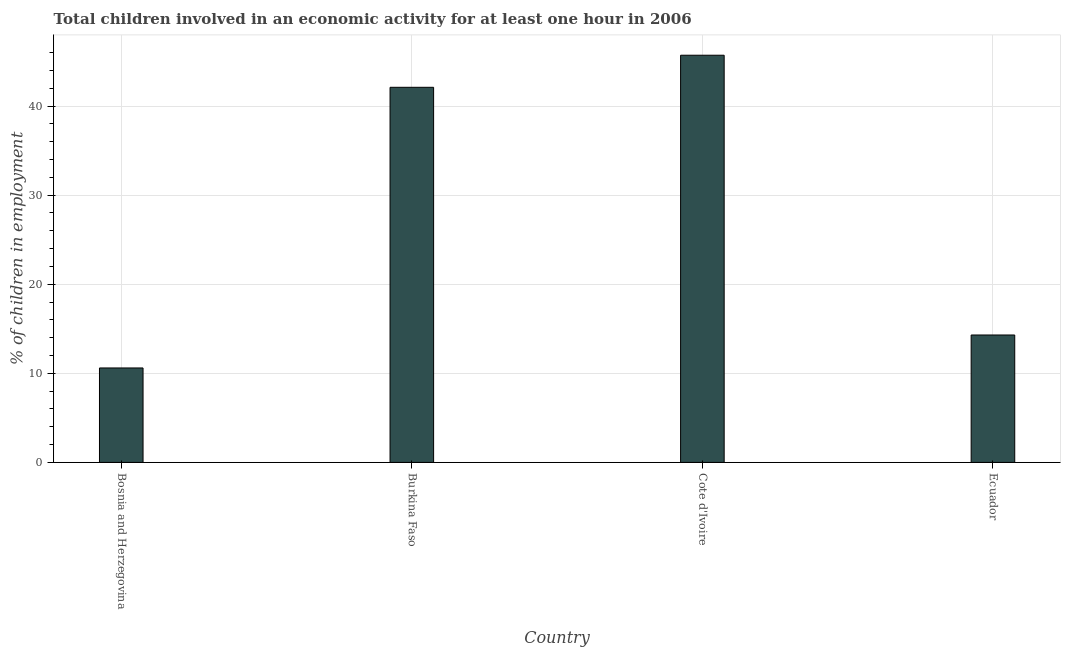What is the title of the graph?
Provide a short and direct response. Total children involved in an economic activity for at least one hour in 2006. What is the label or title of the Y-axis?
Ensure brevity in your answer.  % of children in employment. Across all countries, what is the maximum percentage of children in employment?
Give a very brief answer. 45.7. In which country was the percentage of children in employment maximum?
Provide a short and direct response. Cote d'Ivoire. In which country was the percentage of children in employment minimum?
Give a very brief answer. Bosnia and Herzegovina. What is the sum of the percentage of children in employment?
Ensure brevity in your answer.  112.7. What is the difference between the percentage of children in employment in Bosnia and Herzegovina and Cote d'Ivoire?
Ensure brevity in your answer.  -35.1. What is the average percentage of children in employment per country?
Ensure brevity in your answer.  28.18. What is the median percentage of children in employment?
Offer a terse response. 28.2. In how many countries, is the percentage of children in employment greater than 20 %?
Make the answer very short. 2. What is the ratio of the percentage of children in employment in Burkina Faso to that in Cote d'Ivoire?
Your answer should be compact. 0.92. What is the difference between the highest and the lowest percentage of children in employment?
Offer a very short reply. 35.1. In how many countries, is the percentage of children in employment greater than the average percentage of children in employment taken over all countries?
Provide a succinct answer. 2. Are all the bars in the graph horizontal?
Provide a short and direct response. No. What is the difference between two consecutive major ticks on the Y-axis?
Offer a terse response. 10. What is the % of children in employment in Bosnia and Herzegovina?
Keep it short and to the point. 10.6. What is the % of children in employment of Burkina Faso?
Your answer should be very brief. 42.1. What is the % of children in employment in Cote d'Ivoire?
Offer a terse response. 45.7. What is the difference between the % of children in employment in Bosnia and Herzegovina and Burkina Faso?
Offer a terse response. -31.5. What is the difference between the % of children in employment in Bosnia and Herzegovina and Cote d'Ivoire?
Ensure brevity in your answer.  -35.1. What is the difference between the % of children in employment in Bosnia and Herzegovina and Ecuador?
Offer a terse response. -3.7. What is the difference between the % of children in employment in Burkina Faso and Ecuador?
Provide a succinct answer. 27.8. What is the difference between the % of children in employment in Cote d'Ivoire and Ecuador?
Offer a very short reply. 31.4. What is the ratio of the % of children in employment in Bosnia and Herzegovina to that in Burkina Faso?
Your answer should be compact. 0.25. What is the ratio of the % of children in employment in Bosnia and Herzegovina to that in Cote d'Ivoire?
Keep it short and to the point. 0.23. What is the ratio of the % of children in employment in Bosnia and Herzegovina to that in Ecuador?
Your response must be concise. 0.74. What is the ratio of the % of children in employment in Burkina Faso to that in Cote d'Ivoire?
Your response must be concise. 0.92. What is the ratio of the % of children in employment in Burkina Faso to that in Ecuador?
Provide a short and direct response. 2.94. What is the ratio of the % of children in employment in Cote d'Ivoire to that in Ecuador?
Ensure brevity in your answer.  3.2. 